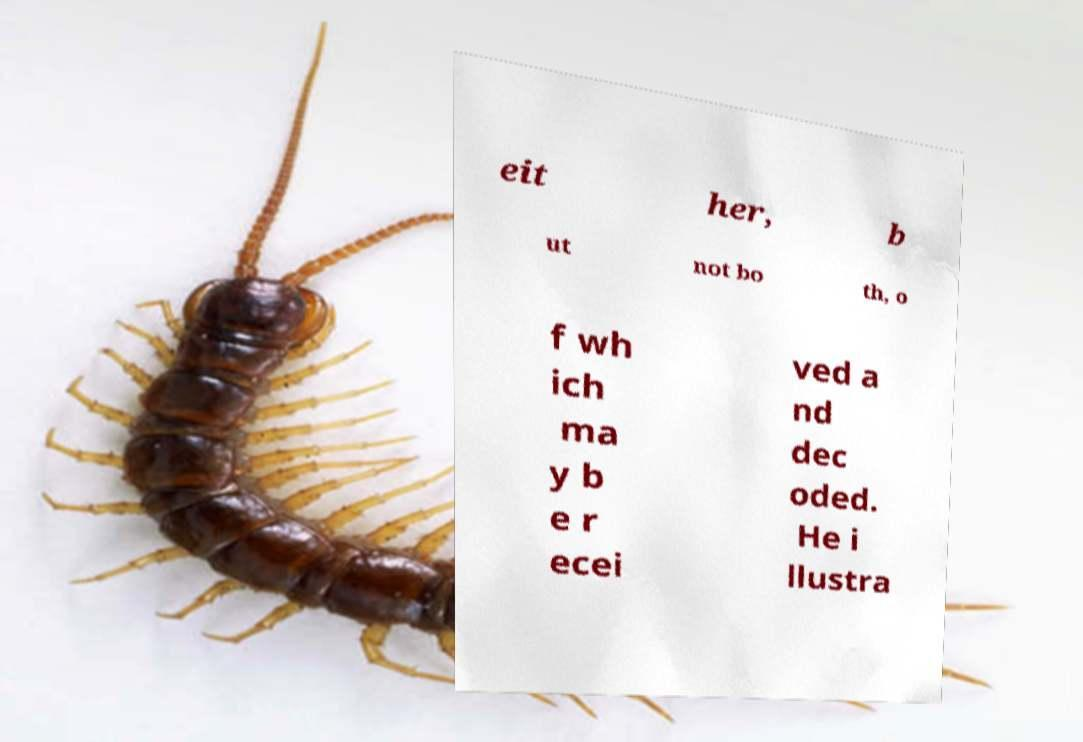Could you extract and type out the text from this image? eit her, b ut not bo th, o f wh ich ma y b e r ecei ved a nd dec oded. He i llustra 